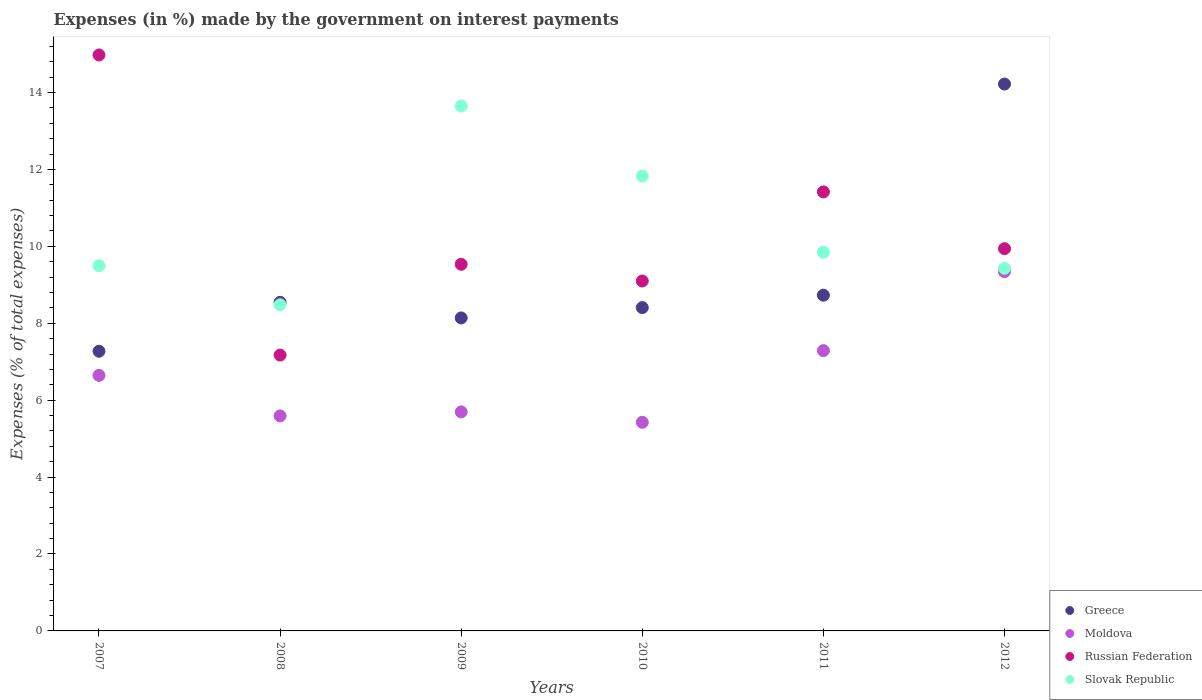Is the number of dotlines equal to the number of legend labels?
Give a very brief answer. Yes. What is the percentage of expenses made by the government on interest payments in Slovak Republic in 2011?
Your response must be concise. 9.85. Across all years, what is the maximum percentage of expenses made by the government on interest payments in Slovak Republic?
Your answer should be compact. 13.65. Across all years, what is the minimum percentage of expenses made by the government on interest payments in Slovak Republic?
Ensure brevity in your answer.  8.48. In which year was the percentage of expenses made by the government on interest payments in Greece maximum?
Provide a short and direct response. 2012. What is the total percentage of expenses made by the government on interest payments in Greece in the graph?
Provide a short and direct response. 55.31. What is the difference between the percentage of expenses made by the government on interest payments in Russian Federation in 2007 and that in 2012?
Make the answer very short. 5.04. What is the difference between the percentage of expenses made by the government on interest payments in Greece in 2012 and the percentage of expenses made by the government on interest payments in Slovak Republic in 2007?
Offer a terse response. 4.72. What is the average percentage of expenses made by the government on interest payments in Greece per year?
Ensure brevity in your answer.  9.22. In the year 2007, what is the difference between the percentage of expenses made by the government on interest payments in Moldova and percentage of expenses made by the government on interest payments in Greece?
Provide a succinct answer. -0.63. What is the ratio of the percentage of expenses made by the government on interest payments in Slovak Republic in 2007 to that in 2011?
Your answer should be very brief. 0.96. Is the percentage of expenses made by the government on interest payments in Moldova in 2010 less than that in 2011?
Make the answer very short. Yes. Is the difference between the percentage of expenses made by the government on interest payments in Moldova in 2008 and 2010 greater than the difference between the percentage of expenses made by the government on interest payments in Greece in 2008 and 2010?
Offer a very short reply. Yes. What is the difference between the highest and the second highest percentage of expenses made by the government on interest payments in Moldova?
Make the answer very short. 2.05. What is the difference between the highest and the lowest percentage of expenses made by the government on interest payments in Moldova?
Offer a very short reply. 3.92. In how many years, is the percentage of expenses made by the government on interest payments in Slovak Republic greater than the average percentage of expenses made by the government on interest payments in Slovak Republic taken over all years?
Your response must be concise. 2. Is it the case that in every year, the sum of the percentage of expenses made by the government on interest payments in Greece and percentage of expenses made by the government on interest payments in Slovak Republic  is greater than the percentage of expenses made by the government on interest payments in Moldova?
Give a very brief answer. Yes. Does the percentage of expenses made by the government on interest payments in Moldova monotonically increase over the years?
Provide a short and direct response. No. How many years are there in the graph?
Your response must be concise. 6. What is the difference between two consecutive major ticks on the Y-axis?
Give a very brief answer. 2. Are the values on the major ticks of Y-axis written in scientific E-notation?
Offer a terse response. No. Does the graph contain any zero values?
Ensure brevity in your answer.  No. Does the graph contain grids?
Ensure brevity in your answer.  No. What is the title of the graph?
Your response must be concise. Expenses (in %) made by the government on interest payments. What is the label or title of the X-axis?
Give a very brief answer. Years. What is the label or title of the Y-axis?
Give a very brief answer. Expenses (% of total expenses). What is the Expenses (% of total expenses) of Greece in 2007?
Ensure brevity in your answer.  7.27. What is the Expenses (% of total expenses) of Moldova in 2007?
Your answer should be compact. 6.64. What is the Expenses (% of total expenses) in Russian Federation in 2007?
Your answer should be very brief. 14.98. What is the Expenses (% of total expenses) of Slovak Republic in 2007?
Offer a terse response. 9.5. What is the Expenses (% of total expenses) of Greece in 2008?
Your response must be concise. 8.54. What is the Expenses (% of total expenses) of Moldova in 2008?
Ensure brevity in your answer.  5.59. What is the Expenses (% of total expenses) in Russian Federation in 2008?
Make the answer very short. 7.17. What is the Expenses (% of total expenses) of Slovak Republic in 2008?
Ensure brevity in your answer.  8.48. What is the Expenses (% of total expenses) in Greece in 2009?
Give a very brief answer. 8.14. What is the Expenses (% of total expenses) in Moldova in 2009?
Give a very brief answer. 5.69. What is the Expenses (% of total expenses) of Russian Federation in 2009?
Offer a very short reply. 9.53. What is the Expenses (% of total expenses) in Slovak Republic in 2009?
Your response must be concise. 13.65. What is the Expenses (% of total expenses) of Greece in 2010?
Ensure brevity in your answer.  8.41. What is the Expenses (% of total expenses) in Moldova in 2010?
Your answer should be compact. 5.42. What is the Expenses (% of total expenses) in Russian Federation in 2010?
Your answer should be compact. 9.1. What is the Expenses (% of total expenses) in Slovak Republic in 2010?
Provide a short and direct response. 11.83. What is the Expenses (% of total expenses) of Greece in 2011?
Your response must be concise. 8.73. What is the Expenses (% of total expenses) of Moldova in 2011?
Offer a terse response. 7.29. What is the Expenses (% of total expenses) in Russian Federation in 2011?
Ensure brevity in your answer.  11.41. What is the Expenses (% of total expenses) of Slovak Republic in 2011?
Offer a terse response. 9.85. What is the Expenses (% of total expenses) in Greece in 2012?
Your answer should be very brief. 14.22. What is the Expenses (% of total expenses) in Moldova in 2012?
Ensure brevity in your answer.  9.34. What is the Expenses (% of total expenses) in Russian Federation in 2012?
Provide a succinct answer. 9.94. What is the Expenses (% of total expenses) of Slovak Republic in 2012?
Give a very brief answer. 9.43. Across all years, what is the maximum Expenses (% of total expenses) of Greece?
Provide a short and direct response. 14.22. Across all years, what is the maximum Expenses (% of total expenses) in Moldova?
Make the answer very short. 9.34. Across all years, what is the maximum Expenses (% of total expenses) in Russian Federation?
Keep it short and to the point. 14.98. Across all years, what is the maximum Expenses (% of total expenses) of Slovak Republic?
Provide a succinct answer. 13.65. Across all years, what is the minimum Expenses (% of total expenses) of Greece?
Give a very brief answer. 7.27. Across all years, what is the minimum Expenses (% of total expenses) of Moldova?
Provide a succinct answer. 5.42. Across all years, what is the minimum Expenses (% of total expenses) in Russian Federation?
Ensure brevity in your answer.  7.17. Across all years, what is the minimum Expenses (% of total expenses) of Slovak Republic?
Ensure brevity in your answer.  8.48. What is the total Expenses (% of total expenses) of Greece in the graph?
Ensure brevity in your answer.  55.31. What is the total Expenses (% of total expenses) of Moldova in the graph?
Make the answer very short. 39.98. What is the total Expenses (% of total expenses) in Russian Federation in the graph?
Offer a very short reply. 62.13. What is the total Expenses (% of total expenses) in Slovak Republic in the graph?
Your answer should be very brief. 62.72. What is the difference between the Expenses (% of total expenses) of Greece in 2007 and that in 2008?
Your answer should be compact. -1.27. What is the difference between the Expenses (% of total expenses) in Moldova in 2007 and that in 2008?
Provide a succinct answer. 1.05. What is the difference between the Expenses (% of total expenses) in Russian Federation in 2007 and that in 2008?
Your answer should be very brief. 7.8. What is the difference between the Expenses (% of total expenses) in Slovak Republic in 2007 and that in 2008?
Keep it short and to the point. 1.01. What is the difference between the Expenses (% of total expenses) in Greece in 2007 and that in 2009?
Offer a very short reply. -0.87. What is the difference between the Expenses (% of total expenses) of Moldova in 2007 and that in 2009?
Provide a succinct answer. 0.95. What is the difference between the Expenses (% of total expenses) in Russian Federation in 2007 and that in 2009?
Keep it short and to the point. 5.44. What is the difference between the Expenses (% of total expenses) of Slovak Republic in 2007 and that in 2009?
Your response must be concise. -4.15. What is the difference between the Expenses (% of total expenses) in Greece in 2007 and that in 2010?
Provide a short and direct response. -1.13. What is the difference between the Expenses (% of total expenses) of Moldova in 2007 and that in 2010?
Offer a very short reply. 1.22. What is the difference between the Expenses (% of total expenses) in Russian Federation in 2007 and that in 2010?
Give a very brief answer. 5.88. What is the difference between the Expenses (% of total expenses) in Slovak Republic in 2007 and that in 2010?
Your answer should be compact. -2.33. What is the difference between the Expenses (% of total expenses) of Greece in 2007 and that in 2011?
Your answer should be very brief. -1.46. What is the difference between the Expenses (% of total expenses) in Moldova in 2007 and that in 2011?
Give a very brief answer. -0.64. What is the difference between the Expenses (% of total expenses) in Russian Federation in 2007 and that in 2011?
Keep it short and to the point. 3.56. What is the difference between the Expenses (% of total expenses) in Slovak Republic in 2007 and that in 2011?
Provide a short and direct response. -0.35. What is the difference between the Expenses (% of total expenses) in Greece in 2007 and that in 2012?
Offer a terse response. -6.95. What is the difference between the Expenses (% of total expenses) of Moldova in 2007 and that in 2012?
Offer a very short reply. -2.7. What is the difference between the Expenses (% of total expenses) of Russian Federation in 2007 and that in 2012?
Make the answer very short. 5.04. What is the difference between the Expenses (% of total expenses) in Slovak Republic in 2007 and that in 2012?
Your response must be concise. 0.07. What is the difference between the Expenses (% of total expenses) of Greece in 2008 and that in 2009?
Your response must be concise. 0.41. What is the difference between the Expenses (% of total expenses) of Moldova in 2008 and that in 2009?
Offer a terse response. -0.1. What is the difference between the Expenses (% of total expenses) in Russian Federation in 2008 and that in 2009?
Keep it short and to the point. -2.36. What is the difference between the Expenses (% of total expenses) of Slovak Republic in 2008 and that in 2009?
Offer a very short reply. -5.17. What is the difference between the Expenses (% of total expenses) in Greece in 2008 and that in 2010?
Make the answer very short. 0.14. What is the difference between the Expenses (% of total expenses) of Moldova in 2008 and that in 2010?
Ensure brevity in your answer.  0.17. What is the difference between the Expenses (% of total expenses) of Russian Federation in 2008 and that in 2010?
Make the answer very short. -1.93. What is the difference between the Expenses (% of total expenses) in Slovak Republic in 2008 and that in 2010?
Give a very brief answer. -3.35. What is the difference between the Expenses (% of total expenses) of Greece in 2008 and that in 2011?
Keep it short and to the point. -0.19. What is the difference between the Expenses (% of total expenses) in Moldova in 2008 and that in 2011?
Your answer should be very brief. -1.7. What is the difference between the Expenses (% of total expenses) in Russian Federation in 2008 and that in 2011?
Ensure brevity in your answer.  -4.24. What is the difference between the Expenses (% of total expenses) in Slovak Republic in 2008 and that in 2011?
Offer a terse response. -1.37. What is the difference between the Expenses (% of total expenses) of Greece in 2008 and that in 2012?
Ensure brevity in your answer.  -5.68. What is the difference between the Expenses (% of total expenses) of Moldova in 2008 and that in 2012?
Provide a short and direct response. -3.75. What is the difference between the Expenses (% of total expenses) in Russian Federation in 2008 and that in 2012?
Your response must be concise. -2.77. What is the difference between the Expenses (% of total expenses) of Slovak Republic in 2008 and that in 2012?
Your answer should be compact. -0.95. What is the difference between the Expenses (% of total expenses) of Greece in 2009 and that in 2010?
Your answer should be very brief. -0.27. What is the difference between the Expenses (% of total expenses) of Moldova in 2009 and that in 2010?
Provide a succinct answer. 0.27. What is the difference between the Expenses (% of total expenses) of Russian Federation in 2009 and that in 2010?
Keep it short and to the point. 0.43. What is the difference between the Expenses (% of total expenses) in Slovak Republic in 2009 and that in 2010?
Provide a short and direct response. 1.82. What is the difference between the Expenses (% of total expenses) of Greece in 2009 and that in 2011?
Offer a terse response. -0.59. What is the difference between the Expenses (% of total expenses) in Moldova in 2009 and that in 2011?
Keep it short and to the point. -1.59. What is the difference between the Expenses (% of total expenses) in Russian Federation in 2009 and that in 2011?
Provide a short and direct response. -1.88. What is the difference between the Expenses (% of total expenses) in Slovak Republic in 2009 and that in 2011?
Keep it short and to the point. 3.8. What is the difference between the Expenses (% of total expenses) in Greece in 2009 and that in 2012?
Provide a short and direct response. -6.08. What is the difference between the Expenses (% of total expenses) of Moldova in 2009 and that in 2012?
Provide a short and direct response. -3.65. What is the difference between the Expenses (% of total expenses) of Russian Federation in 2009 and that in 2012?
Keep it short and to the point. -0.41. What is the difference between the Expenses (% of total expenses) in Slovak Republic in 2009 and that in 2012?
Provide a succinct answer. 4.22. What is the difference between the Expenses (% of total expenses) of Greece in 2010 and that in 2011?
Keep it short and to the point. -0.32. What is the difference between the Expenses (% of total expenses) in Moldova in 2010 and that in 2011?
Make the answer very short. -1.86. What is the difference between the Expenses (% of total expenses) of Russian Federation in 2010 and that in 2011?
Ensure brevity in your answer.  -2.32. What is the difference between the Expenses (% of total expenses) of Slovak Republic in 2010 and that in 2011?
Offer a very short reply. 1.98. What is the difference between the Expenses (% of total expenses) of Greece in 2010 and that in 2012?
Provide a succinct answer. -5.81. What is the difference between the Expenses (% of total expenses) in Moldova in 2010 and that in 2012?
Your answer should be very brief. -3.92. What is the difference between the Expenses (% of total expenses) of Russian Federation in 2010 and that in 2012?
Your answer should be compact. -0.84. What is the difference between the Expenses (% of total expenses) of Slovak Republic in 2010 and that in 2012?
Provide a succinct answer. 2.4. What is the difference between the Expenses (% of total expenses) of Greece in 2011 and that in 2012?
Your answer should be very brief. -5.49. What is the difference between the Expenses (% of total expenses) in Moldova in 2011 and that in 2012?
Offer a terse response. -2.05. What is the difference between the Expenses (% of total expenses) of Russian Federation in 2011 and that in 2012?
Your answer should be very brief. 1.48. What is the difference between the Expenses (% of total expenses) of Slovak Republic in 2011 and that in 2012?
Ensure brevity in your answer.  0.42. What is the difference between the Expenses (% of total expenses) in Greece in 2007 and the Expenses (% of total expenses) in Moldova in 2008?
Offer a very short reply. 1.68. What is the difference between the Expenses (% of total expenses) in Greece in 2007 and the Expenses (% of total expenses) in Russian Federation in 2008?
Give a very brief answer. 0.1. What is the difference between the Expenses (% of total expenses) in Greece in 2007 and the Expenses (% of total expenses) in Slovak Republic in 2008?
Keep it short and to the point. -1.21. What is the difference between the Expenses (% of total expenses) in Moldova in 2007 and the Expenses (% of total expenses) in Russian Federation in 2008?
Your answer should be compact. -0.53. What is the difference between the Expenses (% of total expenses) of Moldova in 2007 and the Expenses (% of total expenses) of Slovak Republic in 2008?
Give a very brief answer. -1.84. What is the difference between the Expenses (% of total expenses) of Russian Federation in 2007 and the Expenses (% of total expenses) of Slovak Republic in 2008?
Provide a short and direct response. 6.5. What is the difference between the Expenses (% of total expenses) of Greece in 2007 and the Expenses (% of total expenses) of Moldova in 2009?
Keep it short and to the point. 1.58. What is the difference between the Expenses (% of total expenses) in Greece in 2007 and the Expenses (% of total expenses) in Russian Federation in 2009?
Give a very brief answer. -2.26. What is the difference between the Expenses (% of total expenses) in Greece in 2007 and the Expenses (% of total expenses) in Slovak Republic in 2009?
Make the answer very short. -6.38. What is the difference between the Expenses (% of total expenses) of Moldova in 2007 and the Expenses (% of total expenses) of Russian Federation in 2009?
Make the answer very short. -2.89. What is the difference between the Expenses (% of total expenses) in Moldova in 2007 and the Expenses (% of total expenses) in Slovak Republic in 2009?
Offer a very short reply. -7. What is the difference between the Expenses (% of total expenses) of Russian Federation in 2007 and the Expenses (% of total expenses) of Slovak Republic in 2009?
Make the answer very short. 1.33. What is the difference between the Expenses (% of total expenses) in Greece in 2007 and the Expenses (% of total expenses) in Moldova in 2010?
Offer a very short reply. 1.85. What is the difference between the Expenses (% of total expenses) in Greece in 2007 and the Expenses (% of total expenses) in Russian Federation in 2010?
Your answer should be compact. -1.83. What is the difference between the Expenses (% of total expenses) in Greece in 2007 and the Expenses (% of total expenses) in Slovak Republic in 2010?
Keep it short and to the point. -4.55. What is the difference between the Expenses (% of total expenses) in Moldova in 2007 and the Expenses (% of total expenses) in Russian Federation in 2010?
Keep it short and to the point. -2.45. What is the difference between the Expenses (% of total expenses) in Moldova in 2007 and the Expenses (% of total expenses) in Slovak Republic in 2010?
Give a very brief answer. -5.18. What is the difference between the Expenses (% of total expenses) in Russian Federation in 2007 and the Expenses (% of total expenses) in Slovak Republic in 2010?
Offer a terse response. 3.15. What is the difference between the Expenses (% of total expenses) in Greece in 2007 and the Expenses (% of total expenses) in Moldova in 2011?
Offer a terse response. -0.02. What is the difference between the Expenses (% of total expenses) of Greece in 2007 and the Expenses (% of total expenses) of Russian Federation in 2011?
Provide a succinct answer. -4.14. What is the difference between the Expenses (% of total expenses) in Greece in 2007 and the Expenses (% of total expenses) in Slovak Republic in 2011?
Your answer should be compact. -2.58. What is the difference between the Expenses (% of total expenses) in Moldova in 2007 and the Expenses (% of total expenses) in Russian Federation in 2011?
Make the answer very short. -4.77. What is the difference between the Expenses (% of total expenses) in Moldova in 2007 and the Expenses (% of total expenses) in Slovak Republic in 2011?
Your response must be concise. -3.2. What is the difference between the Expenses (% of total expenses) of Russian Federation in 2007 and the Expenses (% of total expenses) of Slovak Republic in 2011?
Offer a terse response. 5.13. What is the difference between the Expenses (% of total expenses) in Greece in 2007 and the Expenses (% of total expenses) in Moldova in 2012?
Ensure brevity in your answer.  -2.07. What is the difference between the Expenses (% of total expenses) in Greece in 2007 and the Expenses (% of total expenses) in Russian Federation in 2012?
Provide a short and direct response. -2.67. What is the difference between the Expenses (% of total expenses) in Greece in 2007 and the Expenses (% of total expenses) in Slovak Republic in 2012?
Your response must be concise. -2.16. What is the difference between the Expenses (% of total expenses) in Moldova in 2007 and the Expenses (% of total expenses) in Russian Federation in 2012?
Provide a short and direct response. -3.29. What is the difference between the Expenses (% of total expenses) of Moldova in 2007 and the Expenses (% of total expenses) of Slovak Republic in 2012?
Ensure brevity in your answer.  -2.78. What is the difference between the Expenses (% of total expenses) of Russian Federation in 2007 and the Expenses (% of total expenses) of Slovak Republic in 2012?
Your response must be concise. 5.55. What is the difference between the Expenses (% of total expenses) in Greece in 2008 and the Expenses (% of total expenses) in Moldova in 2009?
Ensure brevity in your answer.  2.85. What is the difference between the Expenses (% of total expenses) of Greece in 2008 and the Expenses (% of total expenses) of Russian Federation in 2009?
Make the answer very short. -0.99. What is the difference between the Expenses (% of total expenses) in Greece in 2008 and the Expenses (% of total expenses) in Slovak Republic in 2009?
Your answer should be very brief. -5.1. What is the difference between the Expenses (% of total expenses) of Moldova in 2008 and the Expenses (% of total expenses) of Russian Federation in 2009?
Your answer should be compact. -3.94. What is the difference between the Expenses (% of total expenses) of Moldova in 2008 and the Expenses (% of total expenses) of Slovak Republic in 2009?
Provide a succinct answer. -8.06. What is the difference between the Expenses (% of total expenses) of Russian Federation in 2008 and the Expenses (% of total expenses) of Slovak Republic in 2009?
Keep it short and to the point. -6.47. What is the difference between the Expenses (% of total expenses) of Greece in 2008 and the Expenses (% of total expenses) of Moldova in 2010?
Your answer should be compact. 3.12. What is the difference between the Expenses (% of total expenses) in Greece in 2008 and the Expenses (% of total expenses) in Russian Federation in 2010?
Your answer should be very brief. -0.55. What is the difference between the Expenses (% of total expenses) in Greece in 2008 and the Expenses (% of total expenses) in Slovak Republic in 2010?
Your answer should be very brief. -3.28. What is the difference between the Expenses (% of total expenses) of Moldova in 2008 and the Expenses (% of total expenses) of Russian Federation in 2010?
Your answer should be very brief. -3.51. What is the difference between the Expenses (% of total expenses) of Moldova in 2008 and the Expenses (% of total expenses) of Slovak Republic in 2010?
Your answer should be very brief. -6.24. What is the difference between the Expenses (% of total expenses) of Russian Federation in 2008 and the Expenses (% of total expenses) of Slovak Republic in 2010?
Ensure brevity in your answer.  -4.65. What is the difference between the Expenses (% of total expenses) of Greece in 2008 and the Expenses (% of total expenses) of Moldova in 2011?
Give a very brief answer. 1.26. What is the difference between the Expenses (% of total expenses) of Greece in 2008 and the Expenses (% of total expenses) of Russian Federation in 2011?
Ensure brevity in your answer.  -2.87. What is the difference between the Expenses (% of total expenses) in Greece in 2008 and the Expenses (% of total expenses) in Slovak Republic in 2011?
Your answer should be compact. -1.3. What is the difference between the Expenses (% of total expenses) in Moldova in 2008 and the Expenses (% of total expenses) in Russian Federation in 2011?
Your response must be concise. -5.82. What is the difference between the Expenses (% of total expenses) in Moldova in 2008 and the Expenses (% of total expenses) in Slovak Republic in 2011?
Keep it short and to the point. -4.26. What is the difference between the Expenses (% of total expenses) in Russian Federation in 2008 and the Expenses (% of total expenses) in Slovak Republic in 2011?
Your answer should be compact. -2.67. What is the difference between the Expenses (% of total expenses) of Greece in 2008 and the Expenses (% of total expenses) of Moldova in 2012?
Your response must be concise. -0.8. What is the difference between the Expenses (% of total expenses) in Greece in 2008 and the Expenses (% of total expenses) in Russian Federation in 2012?
Your response must be concise. -1.39. What is the difference between the Expenses (% of total expenses) of Greece in 2008 and the Expenses (% of total expenses) of Slovak Republic in 2012?
Offer a very short reply. -0.88. What is the difference between the Expenses (% of total expenses) in Moldova in 2008 and the Expenses (% of total expenses) in Russian Federation in 2012?
Your response must be concise. -4.35. What is the difference between the Expenses (% of total expenses) in Moldova in 2008 and the Expenses (% of total expenses) in Slovak Republic in 2012?
Your answer should be compact. -3.84. What is the difference between the Expenses (% of total expenses) in Russian Federation in 2008 and the Expenses (% of total expenses) in Slovak Republic in 2012?
Offer a terse response. -2.25. What is the difference between the Expenses (% of total expenses) of Greece in 2009 and the Expenses (% of total expenses) of Moldova in 2010?
Provide a short and direct response. 2.71. What is the difference between the Expenses (% of total expenses) of Greece in 2009 and the Expenses (% of total expenses) of Russian Federation in 2010?
Offer a terse response. -0.96. What is the difference between the Expenses (% of total expenses) in Greece in 2009 and the Expenses (% of total expenses) in Slovak Republic in 2010?
Provide a short and direct response. -3.69. What is the difference between the Expenses (% of total expenses) of Moldova in 2009 and the Expenses (% of total expenses) of Russian Federation in 2010?
Make the answer very short. -3.4. What is the difference between the Expenses (% of total expenses) of Moldova in 2009 and the Expenses (% of total expenses) of Slovak Republic in 2010?
Your response must be concise. -6.13. What is the difference between the Expenses (% of total expenses) in Russian Federation in 2009 and the Expenses (% of total expenses) in Slovak Republic in 2010?
Offer a very short reply. -2.29. What is the difference between the Expenses (% of total expenses) of Greece in 2009 and the Expenses (% of total expenses) of Russian Federation in 2011?
Your answer should be very brief. -3.28. What is the difference between the Expenses (% of total expenses) in Greece in 2009 and the Expenses (% of total expenses) in Slovak Republic in 2011?
Offer a very short reply. -1.71. What is the difference between the Expenses (% of total expenses) in Moldova in 2009 and the Expenses (% of total expenses) in Russian Federation in 2011?
Keep it short and to the point. -5.72. What is the difference between the Expenses (% of total expenses) of Moldova in 2009 and the Expenses (% of total expenses) of Slovak Republic in 2011?
Give a very brief answer. -4.15. What is the difference between the Expenses (% of total expenses) of Russian Federation in 2009 and the Expenses (% of total expenses) of Slovak Republic in 2011?
Your answer should be compact. -0.31. What is the difference between the Expenses (% of total expenses) of Greece in 2009 and the Expenses (% of total expenses) of Moldova in 2012?
Your answer should be very brief. -1.2. What is the difference between the Expenses (% of total expenses) of Greece in 2009 and the Expenses (% of total expenses) of Russian Federation in 2012?
Your response must be concise. -1.8. What is the difference between the Expenses (% of total expenses) of Greece in 2009 and the Expenses (% of total expenses) of Slovak Republic in 2012?
Ensure brevity in your answer.  -1.29. What is the difference between the Expenses (% of total expenses) in Moldova in 2009 and the Expenses (% of total expenses) in Russian Federation in 2012?
Your response must be concise. -4.24. What is the difference between the Expenses (% of total expenses) of Moldova in 2009 and the Expenses (% of total expenses) of Slovak Republic in 2012?
Keep it short and to the point. -3.73. What is the difference between the Expenses (% of total expenses) of Russian Federation in 2009 and the Expenses (% of total expenses) of Slovak Republic in 2012?
Ensure brevity in your answer.  0.1. What is the difference between the Expenses (% of total expenses) in Greece in 2010 and the Expenses (% of total expenses) in Moldova in 2011?
Offer a very short reply. 1.12. What is the difference between the Expenses (% of total expenses) of Greece in 2010 and the Expenses (% of total expenses) of Russian Federation in 2011?
Offer a very short reply. -3.01. What is the difference between the Expenses (% of total expenses) of Greece in 2010 and the Expenses (% of total expenses) of Slovak Republic in 2011?
Keep it short and to the point. -1.44. What is the difference between the Expenses (% of total expenses) of Moldova in 2010 and the Expenses (% of total expenses) of Russian Federation in 2011?
Keep it short and to the point. -5.99. What is the difference between the Expenses (% of total expenses) of Moldova in 2010 and the Expenses (% of total expenses) of Slovak Republic in 2011?
Your response must be concise. -4.42. What is the difference between the Expenses (% of total expenses) of Russian Federation in 2010 and the Expenses (% of total expenses) of Slovak Republic in 2011?
Your answer should be very brief. -0.75. What is the difference between the Expenses (% of total expenses) of Greece in 2010 and the Expenses (% of total expenses) of Moldova in 2012?
Ensure brevity in your answer.  -0.94. What is the difference between the Expenses (% of total expenses) of Greece in 2010 and the Expenses (% of total expenses) of Russian Federation in 2012?
Your response must be concise. -1.53. What is the difference between the Expenses (% of total expenses) in Greece in 2010 and the Expenses (% of total expenses) in Slovak Republic in 2012?
Keep it short and to the point. -1.02. What is the difference between the Expenses (% of total expenses) of Moldova in 2010 and the Expenses (% of total expenses) of Russian Federation in 2012?
Provide a short and direct response. -4.51. What is the difference between the Expenses (% of total expenses) of Moldova in 2010 and the Expenses (% of total expenses) of Slovak Republic in 2012?
Your answer should be very brief. -4. What is the difference between the Expenses (% of total expenses) in Russian Federation in 2010 and the Expenses (% of total expenses) in Slovak Republic in 2012?
Keep it short and to the point. -0.33. What is the difference between the Expenses (% of total expenses) in Greece in 2011 and the Expenses (% of total expenses) in Moldova in 2012?
Provide a succinct answer. -0.61. What is the difference between the Expenses (% of total expenses) in Greece in 2011 and the Expenses (% of total expenses) in Russian Federation in 2012?
Provide a succinct answer. -1.21. What is the difference between the Expenses (% of total expenses) of Greece in 2011 and the Expenses (% of total expenses) of Slovak Republic in 2012?
Give a very brief answer. -0.7. What is the difference between the Expenses (% of total expenses) in Moldova in 2011 and the Expenses (% of total expenses) in Russian Federation in 2012?
Your answer should be compact. -2.65. What is the difference between the Expenses (% of total expenses) in Moldova in 2011 and the Expenses (% of total expenses) in Slovak Republic in 2012?
Your response must be concise. -2.14. What is the difference between the Expenses (% of total expenses) in Russian Federation in 2011 and the Expenses (% of total expenses) in Slovak Republic in 2012?
Make the answer very short. 1.99. What is the average Expenses (% of total expenses) of Greece per year?
Provide a succinct answer. 9.22. What is the average Expenses (% of total expenses) in Moldova per year?
Offer a very short reply. 6.66. What is the average Expenses (% of total expenses) of Russian Federation per year?
Offer a very short reply. 10.36. What is the average Expenses (% of total expenses) in Slovak Republic per year?
Your response must be concise. 10.45. In the year 2007, what is the difference between the Expenses (% of total expenses) of Greece and Expenses (% of total expenses) of Moldova?
Your response must be concise. 0.63. In the year 2007, what is the difference between the Expenses (% of total expenses) in Greece and Expenses (% of total expenses) in Russian Federation?
Ensure brevity in your answer.  -7.7. In the year 2007, what is the difference between the Expenses (% of total expenses) in Greece and Expenses (% of total expenses) in Slovak Republic?
Ensure brevity in your answer.  -2.22. In the year 2007, what is the difference between the Expenses (% of total expenses) of Moldova and Expenses (% of total expenses) of Russian Federation?
Keep it short and to the point. -8.33. In the year 2007, what is the difference between the Expenses (% of total expenses) in Moldova and Expenses (% of total expenses) in Slovak Republic?
Offer a terse response. -2.85. In the year 2007, what is the difference between the Expenses (% of total expenses) in Russian Federation and Expenses (% of total expenses) in Slovak Republic?
Provide a short and direct response. 5.48. In the year 2008, what is the difference between the Expenses (% of total expenses) of Greece and Expenses (% of total expenses) of Moldova?
Provide a succinct answer. 2.95. In the year 2008, what is the difference between the Expenses (% of total expenses) in Greece and Expenses (% of total expenses) in Russian Federation?
Provide a succinct answer. 1.37. In the year 2008, what is the difference between the Expenses (% of total expenses) of Greece and Expenses (% of total expenses) of Slovak Republic?
Provide a succinct answer. 0.06. In the year 2008, what is the difference between the Expenses (% of total expenses) of Moldova and Expenses (% of total expenses) of Russian Federation?
Provide a succinct answer. -1.58. In the year 2008, what is the difference between the Expenses (% of total expenses) of Moldova and Expenses (% of total expenses) of Slovak Republic?
Your answer should be compact. -2.89. In the year 2008, what is the difference between the Expenses (% of total expenses) of Russian Federation and Expenses (% of total expenses) of Slovak Republic?
Your answer should be very brief. -1.31. In the year 2009, what is the difference between the Expenses (% of total expenses) of Greece and Expenses (% of total expenses) of Moldova?
Your response must be concise. 2.44. In the year 2009, what is the difference between the Expenses (% of total expenses) of Greece and Expenses (% of total expenses) of Russian Federation?
Ensure brevity in your answer.  -1.39. In the year 2009, what is the difference between the Expenses (% of total expenses) of Greece and Expenses (% of total expenses) of Slovak Republic?
Ensure brevity in your answer.  -5.51. In the year 2009, what is the difference between the Expenses (% of total expenses) in Moldova and Expenses (% of total expenses) in Russian Federation?
Keep it short and to the point. -3.84. In the year 2009, what is the difference between the Expenses (% of total expenses) in Moldova and Expenses (% of total expenses) in Slovak Republic?
Your response must be concise. -7.95. In the year 2009, what is the difference between the Expenses (% of total expenses) of Russian Federation and Expenses (% of total expenses) of Slovak Republic?
Provide a short and direct response. -4.12. In the year 2010, what is the difference between the Expenses (% of total expenses) in Greece and Expenses (% of total expenses) in Moldova?
Your response must be concise. 2.98. In the year 2010, what is the difference between the Expenses (% of total expenses) of Greece and Expenses (% of total expenses) of Russian Federation?
Your answer should be compact. -0.69. In the year 2010, what is the difference between the Expenses (% of total expenses) of Greece and Expenses (% of total expenses) of Slovak Republic?
Your answer should be compact. -3.42. In the year 2010, what is the difference between the Expenses (% of total expenses) of Moldova and Expenses (% of total expenses) of Russian Federation?
Offer a terse response. -3.67. In the year 2010, what is the difference between the Expenses (% of total expenses) in Moldova and Expenses (% of total expenses) in Slovak Republic?
Ensure brevity in your answer.  -6.4. In the year 2010, what is the difference between the Expenses (% of total expenses) of Russian Federation and Expenses (% of total expenses) of Slovak Republic?
Give a very brief answer. -2.73. In the year 2011, what is the difference between the Expenses (% of total expenses) of Greece and Expenses (% of total expenses) of Moldova?
Give a very brief answer. 1.44. In the year 2011, what is the difference between the Expenses (% of total expenses) of Greece and Expenses (% of total expenses) of Russian Federation?
Make the answer very short. -2.68. In the year 2011, what is the difference between the Expenses (% of total expenses) of Greece and Expenses (% of total expenses) of Slovak Republic?
Offer a very short reply. -1.12. In the year 2011, what is the difference between the Expenses (% of total expenses) in Moldova and Expenses (% of total expenses) in Russian Federation?
Ensure brevity in your answer.  -4.13. In the year 2011, what is the difference between the Expenses (% of total expenses) of Moldova and Expenses (% of total expenses) of Slovak Republic?
Your response must be concise. -2.56. In the year 2011, what is the difference between the Expenses (% of total expenses) in Russian Federation and Expenses (% of total expenses) in Slovak Republic?
Offer a terse response. 1.57. In the year 2012, what is the difference between the Expenses (% of total expenses) of Greece and Expenses (% of total expenses) of Moldova?
Give a very brief answer. 4.88. In the year 2012, what is the difference between the Expenses (% of total expenses) in Greece and Expenses (% of total expenses) in Russian Federation?
Give a very brief answer. 4.28. In the year 2012, what is the difference between the Expenses (% of total expenses) of Greece and Expenses (% of total expenses) of Slovak Republic?
Your answer should be very brief. 4.79. In the year 2012, what is the difference between the Expenses (% of total expenses) in Moldova and Expenses (% of total expenses) in Russian Federation?
Ensure brevity in your answer.  -0.6. In the year 2012, what is the difference between the Expenses (% of total expenses) of Moldova and Expenses (% of total expenses) of Slovak Republic?
Offer a terse response. -0.09. In the year 2012, what is the difference between the Expenses (% of total expenses) in Russian Federation and Expenses (% of total expenses) in Slovak Republic?
Your answer should be compact. 0.51. What is the ratio of the Expenses (% of total expenses) of Greece in 2007 to that in 2008?
Provide a short and direct response. 0.85. What is the ratio of the Expenses (% of total expenses) of Moldova in 2007 to that in 2008?
Ensure brevity in your answer.  1.19. What is the ratio of the Expenses (% of total expenses) of Russian Federation in 2007 to that in 2008?
Provide a short and direct response. 2.09. What is the ratio of the Expenses (% of total expenses) in Slovak Republic in 2007 to that in 2008?
Offer a terse response. 1.12. What is the ratio of the Expenses (% of total expenses) in Greece in 2007 to that in 2009?
Provide a short and direct response. 0.89. What is the ratio of the Expenses (% of total expenses) in Moldova in 2007 to that in 2009?
Your response must be concise. 1.17. What is the ratio of the Expenses (% of total expenses) in Russian Federation in 2007 to that in 2009?
Provide a succinct answer. 1.57. What is the ratio of the Expenses (% of total expenses) of Slovak Republic in 2007 to that in 2009?
Give a very brief answer. 0.7. What is the ratio of the Expenses (% of total expenses) of Greece in 2007 to that in 2010?
Keep it short and to the point. 0.86. What is the ratio of the Expenses (% of total expenses) of Moldova in 2007 to that in 2010?
Offer a very short reply. 1.22. What is the ratio of the Expenses (% of total expenses) in Russian Federation in 2007 to that in 2010?
Your answer should be very brief. 1.65. What is the ratio of the Expenses (% of total expenses) of Slovak Republic in 2007 to that in 2010?
Your response must be concise. 0.8. What is the ratio of the Expenses (% of total expenses) of Greece in 2007 to that in 2011?
Offer a very short reply. 0.83. What is the ratio of the Expenses (% of total expenses) in Moldova in 2007 to that in 2011?
Make the answer very short. 0.91. What is the ratio of the Expenses (% of total expenses) of Russian Federation in 2007 to that in 2011?
Your answer should be compact. 1.31. What is the ratio of the Expenses (% of total expenses) in Greece in 2007 to that in 2012?
Give a very brief answer. 0.51. What is the ratio of the Expenses (% of total expenses) of Moldova in 2007 to that in 2012?
Make the answer very short. 0.71. What is the ratio of the Expenses (% of total expenses) in Russian Federation in 2007 to that in 2012?
Keep it short and to the point. 1.51. What is the ratio of the Expenses (% of total expenses) in Greece in 2008 to that in 2009?
Your answer should be very brief. 1.05. What is the ratio of the Expenses (% of total expenses) of Moldova in 2008 to that in 2009?
Your answer should be compact. 0.98. What is the ratio of the Expenses (% of total expenses) in Russian Federation in 2008 to that in 2009?
Your answer should be very brief. 0.75. What is the ratio of the Expenses (% of total expenses) of Slovak Republic in 2008 to that in 2009?
Offer a terse response. 0.62. What is the ratio of the Expenses (% of total expenses) in Greece in 2008 to that in 2010?
Make the answer very short. 1.02. What is the ratio of the Expenses (% of total expenses) of Moldova in 2008 to that in 2010?
Provide a short and direct response. 1.03. What is the ratio of the Expenses (% of total expenses) in Russian Federation in 2008 to that in 2010?
Your answer should be very brief. 0.79. What is the ratio of the Expenses (% of total expenses) in Slovak Republic in 2008 to that in 2010?
Offer a terse response. 0.72. What is the ratio of the Expenses (% of total expenses) of Greece in 2008 to that in 2011?
Your answer should be compact. 0.98. What is the ratio of the Expenses (% of total expenses) in Moldova in 2008 to that in 2011?
Offer a very short reply. 0.77. What is the ratio of the Expenses (% of total expenses) in Russian Federation in 2008 to that in 2011?
Your answer should be compact. 0.63. What is the ratio of the Expenses (% of total expenses) of Slovak Republic in 2008 to that in 2011?
Ensure brevity in your answer.  0.86. What is the ratio of the Expenses (% of total expenses) in Greece in 2008 to that in 2012?
Make the answer very short. 0.6. What is the ratio of the Expenses (% of total expenses) in Moldova in 2008 to that in 2012?
Make the answer very short. 0.6. What is the ratio of the Expenses (% of total expenses) of Russian Federation in 2008 to that in 2012?
Provide a short and direct response. 0.72. What is the ratio of the Expenses (% of total expenses) in Slovak Republic in 2008 to that in 2012?
Keep it short and to the point. 0.9. What is the ratio of the Expenses (% of total expenses) of Greece in 2009 to that in 2010?
Offer a very short reply. 0.97. What is the ratio of the Expenses (% of total expenses) in Moldova in 2009 to that in 2010?
Offer a very short reply. 1.05. What is the ratio of the Expenses (% of total expenses) of Russian Federation in 2009 to that in 2010?
Ensure brevity in your answer.  1.05. What is the ratio of the Expenses (% of total expenses) of Slovak Republic in 2009 to that in 2010?
Make the answer very short. 1.15. What is the ratio of the Expenses (% of total expenses) in Greece in 2009 to that in 2011?
Provide a succinct answer. 0.93. What is the ratio of the Expenses (% of total expenses) in Moldova in 2009 to that in 2011?
Your response must be concise. 0.78. What is the ratio of the Expenses (% of total expenses) of Russian Federation in 2009 to that in 2011?
Make the answer very short. 0.84. What is the ratio of the Expenses (% of total expenses) of Slovak Republic in 2009 to that in 2011?
Make the answer very short. 1.39. What is the ratio of the Expenses (% of total expenses) in Greece in 2009 to that in 2012?
Your answer should be compact. 0.57. What is the ratio of the Expenses (% of total expenses) in Moldova in 2009 to that in 2012?
Offer a terse response. 0.61. What is the ratio of the Expenses (% of total expenses) in Russian Federation in 2009 to that in 2012?
Your answer should be compact. 0.96. What is the ratio of the Expenses (% of total expenses) of Slovak Republic in 2009 to that in 2012?
Provide a short and direct response. 1.45. What is the ratio of the Expenses (% of total expenses) of Greece in 2010 to that in 2011?
Provide a succinct answer. 0.96. What is the ratio of the Expenses (% of total expenses) of Moldova in 2010 to that in 2011?
Keep it short and to the point. 0.74. What is the ratio of the Expenses (% of total expenses) in Russian Federation in 2010 to that in 2011?
Your answer should be very brief. 0.8. What is the ratio of the Expenses (% of total expenses) in Slovak Republic in 2010 to that in 2011?
Provide a short and direct response. 1.2. What is the ratio of the Expenses (% of total expenses) of Greece in 2010 to that in 2012?
Offer a terse response. 0.59. What is the ratio of the Expenses (% of total expenses) in Moldova in 2010 to that in 2012?
Provide a short and direct response. 0.58. What is the ratio of the Expenses (% of total expenses) of Russian Federation in 2010 to that in 2012?
Ensure brevity in your answer.  0.92. What is the ratio of the Expenses (% of total expenses) in Slovak Republic in 2010 to that in 2012?
Your answer should be very brief. 1.25. What is the ratio of the Expenses (% of total expenses) of Greece in 2011 to that in 2012?
Make the answer very short. 0.61. What is the ratio of the Expenses (% of total expenses) of Moldova in 2011 to that in 2012?
Your response must be concise. 0.78. What is the ratio of the Expenses (% of total expenses) of Russian Federation in 2011 to that in 2012?
Your answer should be very brief. 1.15. What is the ratio of the Expenses (% of total expenses) of Slovak Republic in 2011 to that in 2012?
Give a very brief answer. 1.04. What is the difference between the highest and the second highest Expenses (% of total expenses) of Greece?
Make the answer very short. 5.49. What is the difference between the highest and the second highest Expenses (% of total expenses) in Moldova?
Your answer should be compact. 2.05. What is the difference between the highest and the second highest Expenses (% of total expenses) of Russian Federation?
Offer a terse response. 3.56. What is the difference between the highest and the second highest Expenses (% of total expenses) of Slovak Republic?
Your answer should be very brief. 1.82. What is the difference between the highest and the lowest Expenses (% of total expenses) in Greece?
Give a very brief answer. 6.95. What is the difference between the highest and the lowest Expenses (% of total expenses) of Moldova?
Provide a short and direct response. 3.92. What is the difference between the highest and the lowest Expenses (% of total expenses) in Russian Federation?
Make the answer very short. 7.8. What is the difference between the highest and the lowest Expenses (% of total expenses) of Slovak Republic?
Make the answer very short. 5.17. 